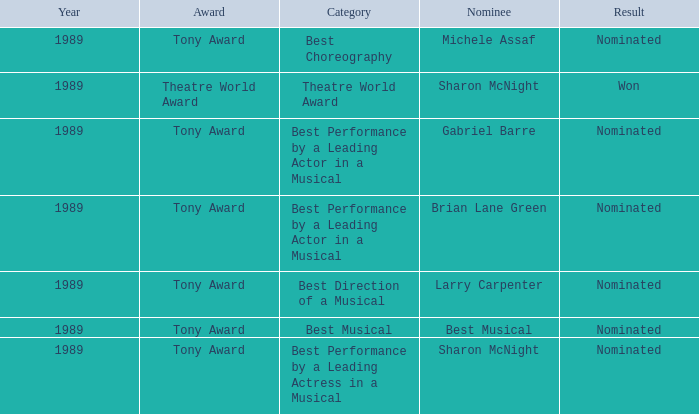What was the nominee of best musical Best Musical. 